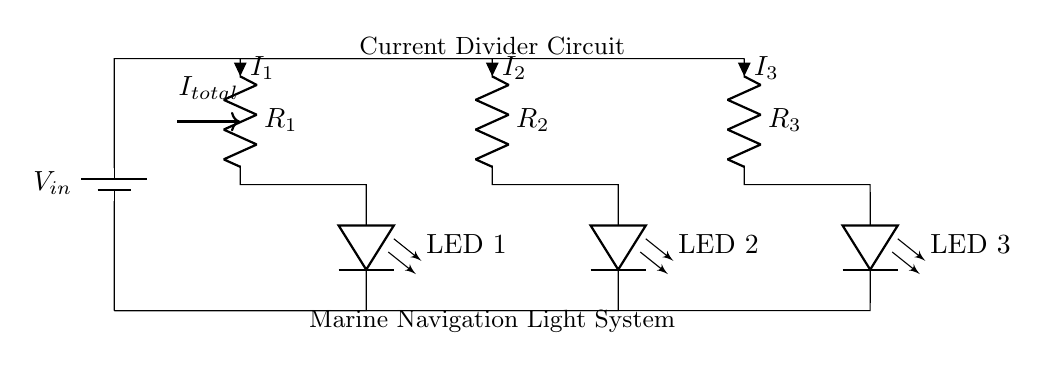What are the resistances in the circuit? The circuit has three resistors: R1, R2, and R3. The values of these resistors are not provided in the diagram but they are labeled clearly.
Answer: R1, R2, R3 How many LEDs are present in the circuit? There are three LEDs indicated in the diagram, each connected to its own resistor.
Answer: 3 What is the role of the resistors in this circuit? The resistors reduce the current flowing through each LED according to Ohm's law, allowing for different brightness levels or functioning as a current divider. This ensures that the LEDs operate safely without burning out.
Answer: Current limiting What is the total current entering the circuit? The total current entering the circuit is indicated by the label I_total at the entry point of the main power source, which is the sum of the currents flowing through R1, R2, and R3.
Answer: I_total If R2 has a resistance of 100 ohms, what is the current I2 if the input voltage is 12 volts? To find I2, apply Ohm's law: I2 = V/R2. Therefore, I2 = 12V / 100 ohms = 0.12A. This represents the current through that specific resistor and LED.
Answer: 0.12A What type of circuit configuration is shown in the diagram? The circuit configuration is a current divider, characterized by multiple paths (R1, R2, and R3) allowing for division of current among the parallel branches connected to the same voltage source.
Answer: Current divider What happens to the brightness of the LEDs if one resistor value is decreased? If one resistor, say R1, is decreased, the current through that branch (LED 1) will increase, causing LED 1 to become brighter, while the overall total current remains constant assuming the voltage source does not change.
Answer: Brighter LED 1 